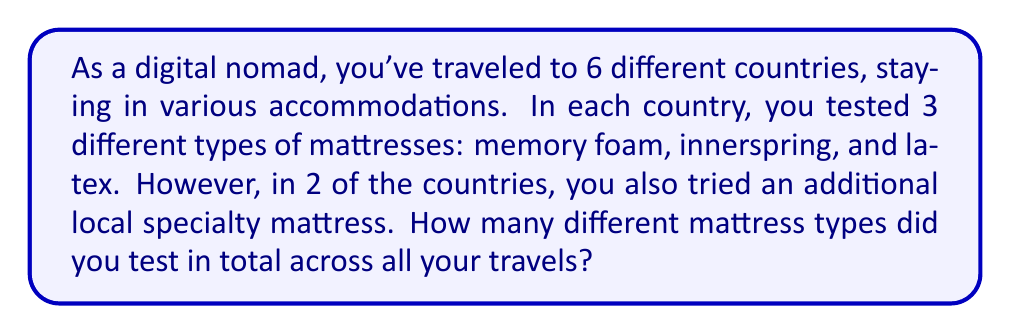Show me your answer to this math problem. Let's break this down step-by-step:

1. First, let's count the standard mattress types:
   - There are 3 standard types: memory foam, innerspring, and latex.
   - You tested these in all 6 countries.
   - So, the count for standard types is: $3$

2. Now, let's consider the local specialty mattresses:
   - You tried these in 2 of the countries.
   - Each country had a different specialty mattress.
   - So, the count for specialty types is: $2$

3. To get the total count, we sum the standard and specialty types:
   $$\text{Total} = \text{Standard types} + \text{Specialty types}$$
   $$\text{Total} = 3 + 2 = 5$$

Therefore, you tested 5 different mattress types in total across all your travels.
Answer: 5 